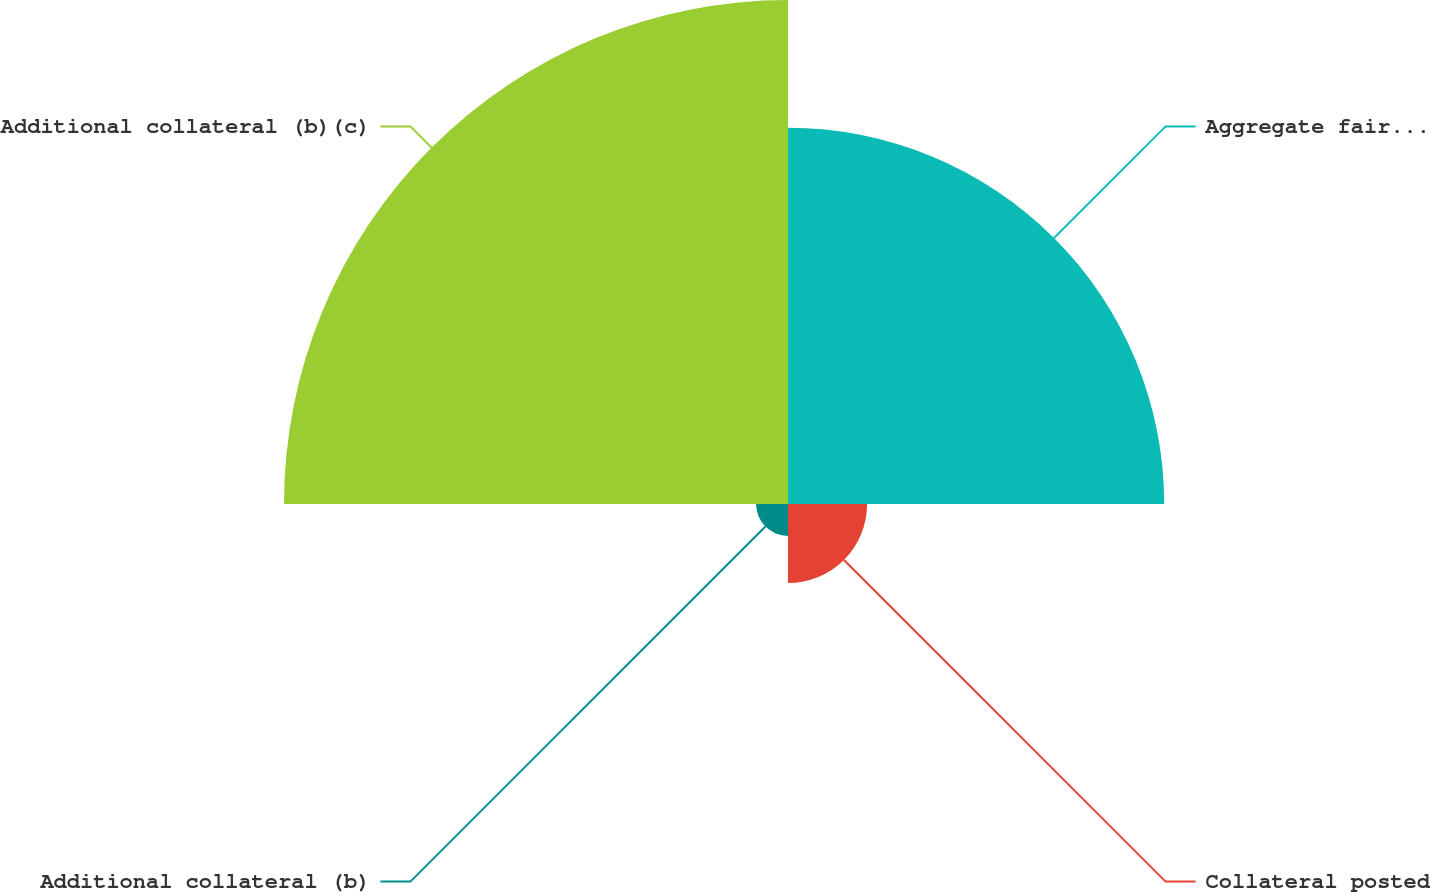Convert chart to OTSL. <chart><loc_0><loc_0><loc_500><loc_500><pie_chart><fcel>Aggregate fair value - net<fcel>Collateral posted<fcel>Additional collateral (b)<fcel>Additional collateral (b)(c)<nl><fcel>37.95%<fcel>7.98%<fcel>3.22%<fcel>50.84%<nl></chart> 